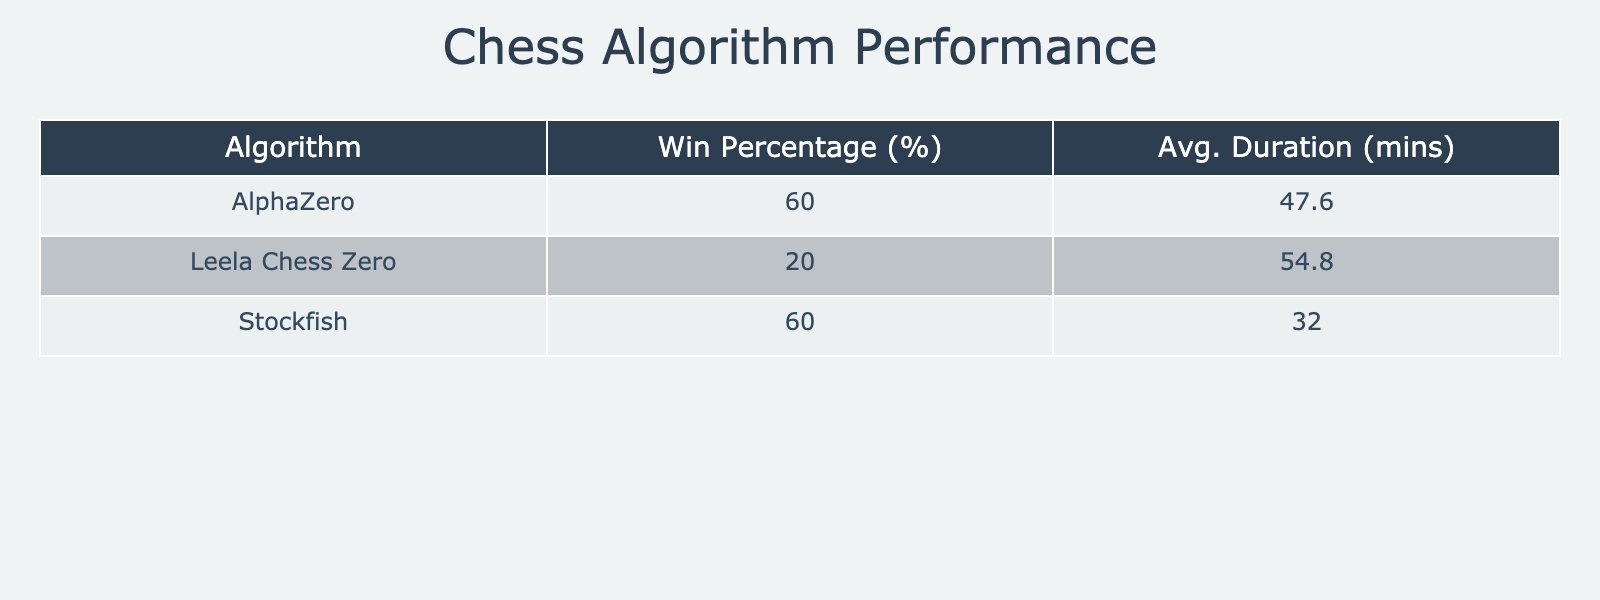What is the win percentage of Stockfish? From the table, we see Stockfish has 6 matches and out of those, it won 4 (against a human player, Grandmaster, another computer player, and in a rapid match). The win percentage is calculated as (4 wins / 6 matches) * 100 = 66.67%.
Answer: 66.67% Which algorithm has the highest average match duration? We can examine the average durations for each algorithm: Stockfish (45 + 55 + 5 + 30 + 25 = 160 / 6 = 26.67), AlphaZero (120 + 70 + 10 + 3 + 35 = 238 / 5 = 47.6), and Leela Chess Zero (60 + 80 + 40 + 90 + 4 = 274 / 5 = 54.8). The highest average duration is for AlphaZero at 47.6 minutes.
Answer: AlphaZero Did any algorithm achieve a win against a Grandmaster? According to the data, only Stockfish achieved a win against a Grandmaster in a rapid match, while AlphaZero lost to a Grandmaster. Thus, the answer is yes.
Answer: Yes What is the average duration of matches for Leela Chess Zero? The durations for Leela Chess Zero are 60, 90, 40, and 4 minutes. Thus, the average is (60 + 90 + 40 + 4) / 4 = 48.5 minutes.
Answer: 48.5 Which algorithm had the most draws and what was the win percentage of that algorithm? Analyzing the table, Stockfish and AlphaZero each had 2 draws, and Leela Chess Zero had 1. Now we'll find the win percentage: Stockfish's win percentage is 66.67%, and AlphaZero's win percentage is 60%. Thus, Stockfish has the most draws with the highest win percentage of 66.67%.
Answer: Stockfish, 66.67% 